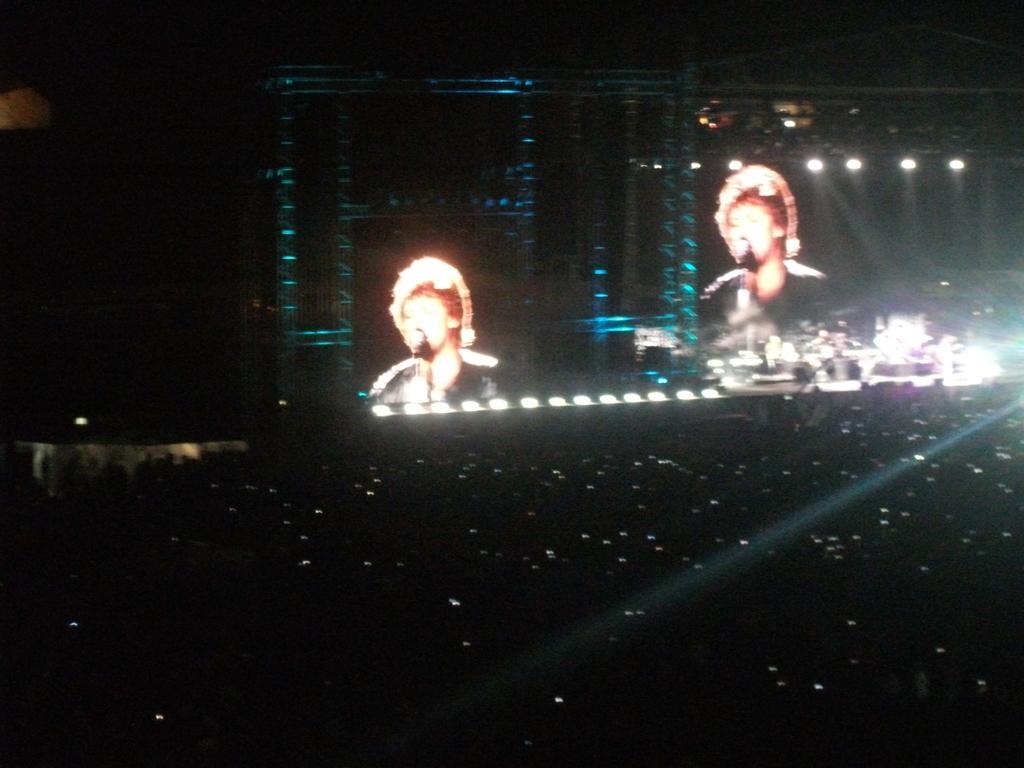Describe this image in one or two sentences. In the image we can see projected screens, lights and the background is dark.  